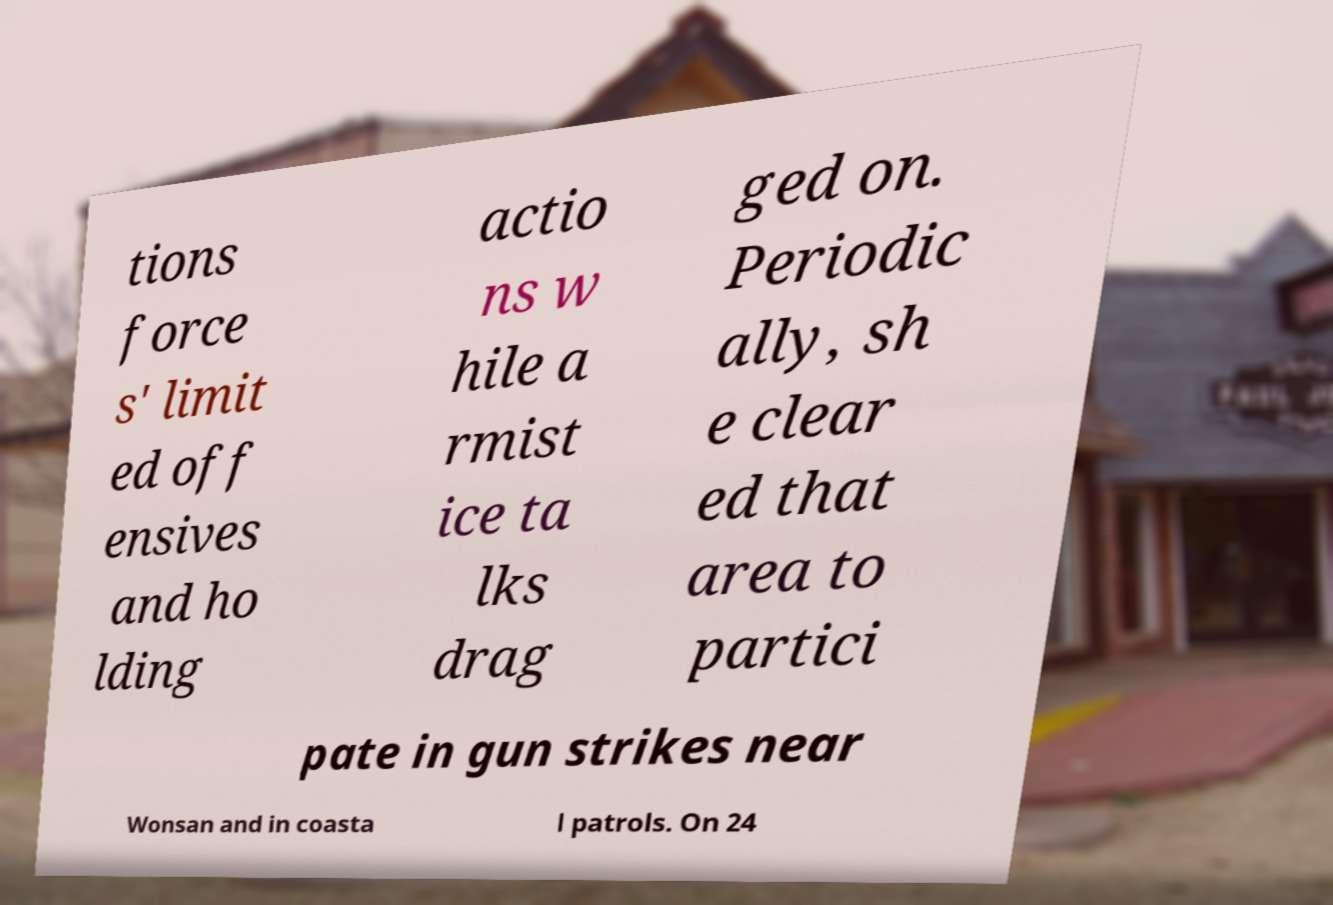Can you accurately transcribe the text from the provided image for me? tions force s' limit ed off ensives and ho lding actio ns w hile a rmist ice ta lks drag ged on. Periodic ally, sh e clear ed that area to partici pate in gun strikes near Wonsan and in coasta l patrols. On 24 